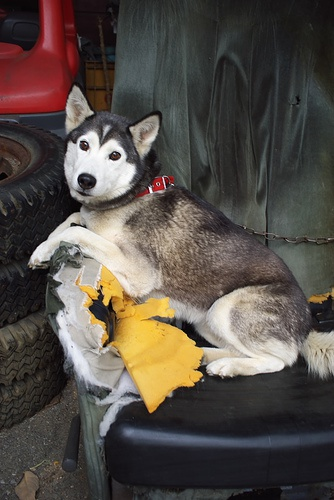Describe the objects in this image and their specific colors. I can see dog in black, gray, lightgray, and darkgray tones and chair in black and gray tones in this image. 